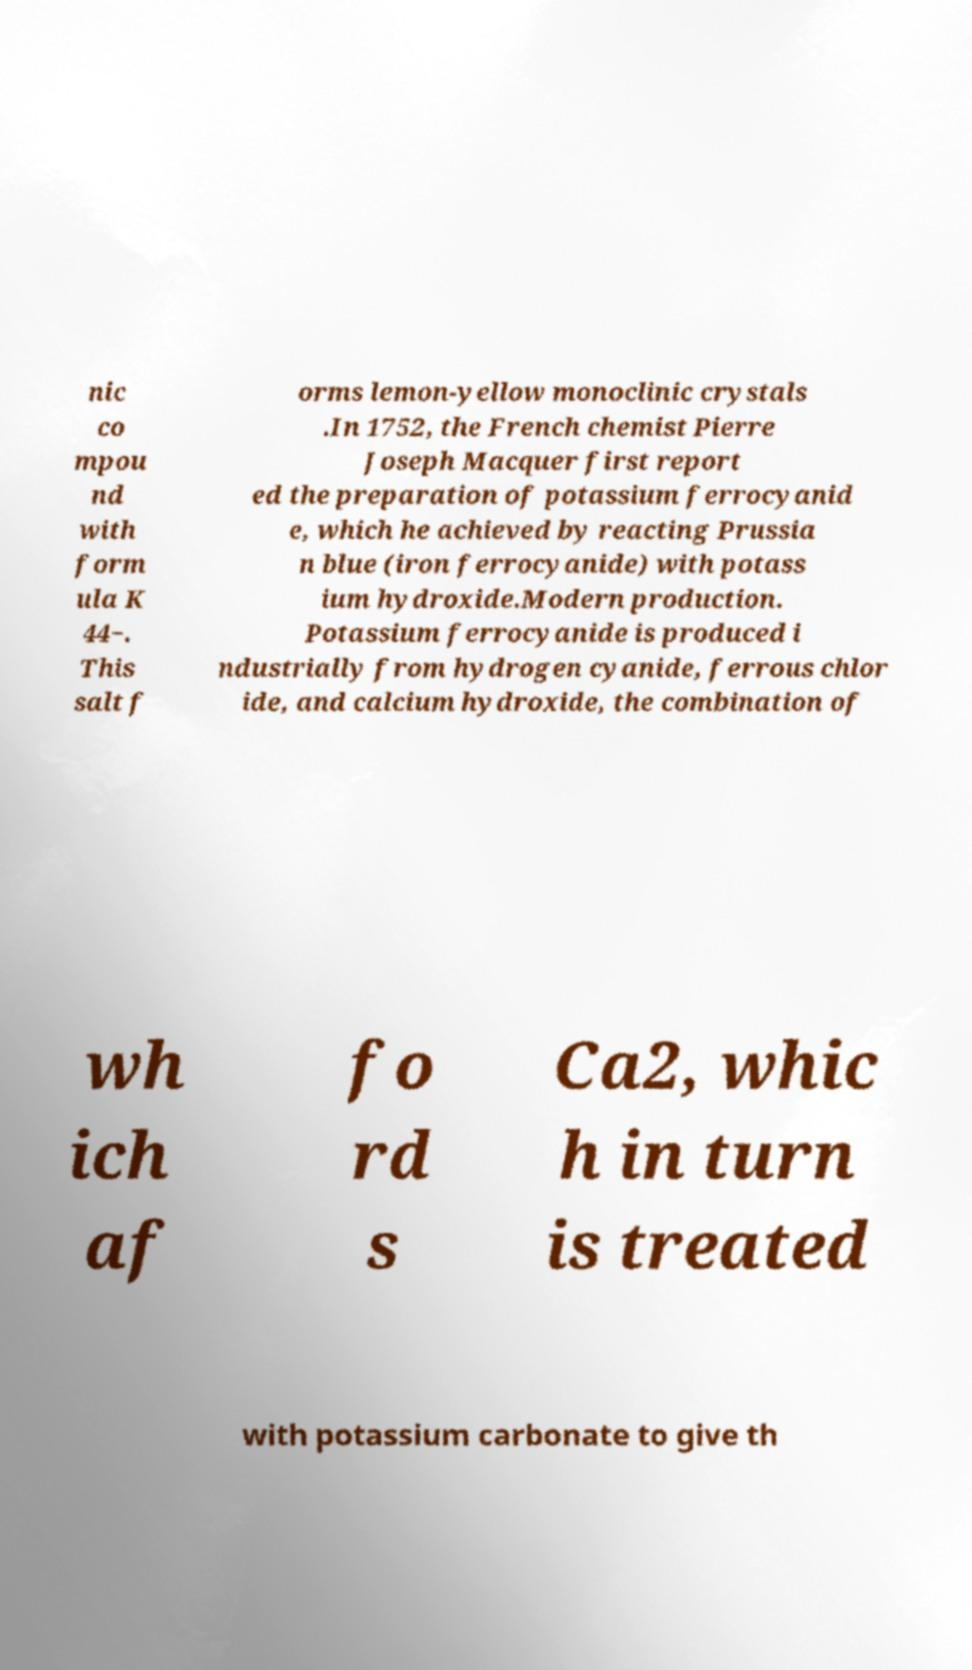I need the written content from this picture converted into text. Can you do that? nic co mpou nd with form ula K 44−. This salt f orms lemon-yellow monoclinic crystals .In 1752, the French chemist Pierre Joseph Macquer first report ed the preparation of potassium ferrocyanid e, which he achieved by reacting Prussia n blue (iron ferrocyanide) with potass ium hydroxide.Modern production. Potassium ferrocyanide is produced i ndustrially from hydrogen cyanide, ferrous chlor ide, and calcium hydroxide, the combination of wh ich af fo rd s Ca2, whic h in turn is treated with potassium carbonate to give th 